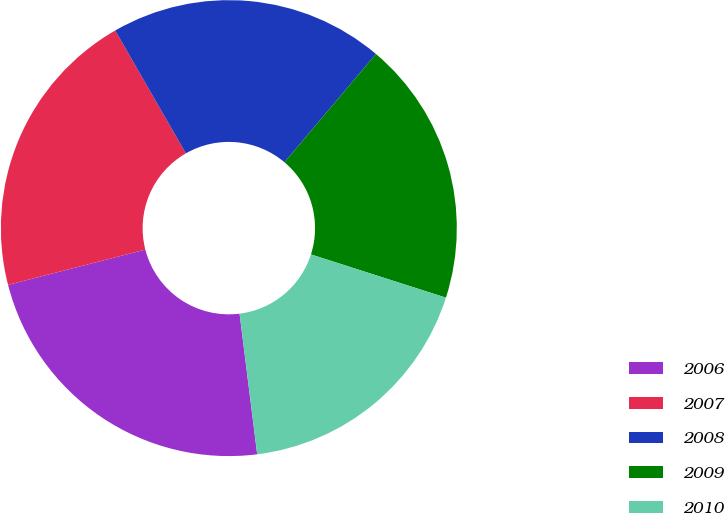<chart> <loc_0><loc_0><loc_500><loc_500><pie_chart><fcel>2006<fcel>2007<fcel>2008<fcel>2009<fcel>2010<nl><fcel>22.98%<fcel>20.7%<fcel>19.47%<fcel>18.77%<fcel>18.08%<nl></chart> 